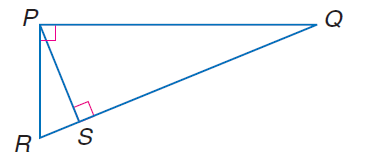Answer the mathemtical geometry problem and directly provide the correct option letter.
Question: In \triangle P Q R, R S = 3 and Q S = 14. Find P S.
Choices: A: \sqrt { 14 } B: \sqrt { 42 } C: \sqrt { 47 } D: \sqrt { 205 } B 